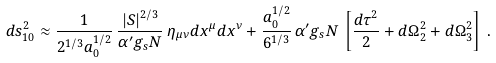<formula> <loc_0><loc_0><loc_500><loc_500>d s _ { 1 0 } ^ { 2 } \approx \frac { 1 } { 2 ^ { 1 / 3 } a _ { 0 } ^ { 1 / 2 } } \, \frac { | S | ^ { 2 / 3 } } { \alpha ^ { \prime } g _ { s } N } \, \eta _ { \mu \nu } d x ^ { \mu } d x ^ { \nu } + \frac { a _ { 0 } ^ { 1 / 2 } } { 6 ^ { 1 / 3 } } \, \alpha ^ { \prime } g _ { s } N \, \left [ \frac { d \tau ^ { 2 } } { 2 } + d \Omega _ { 2 } ^ { 2 } + d \Omega _ { 3 } ^ { 2 } \right ] \, .</formula> 